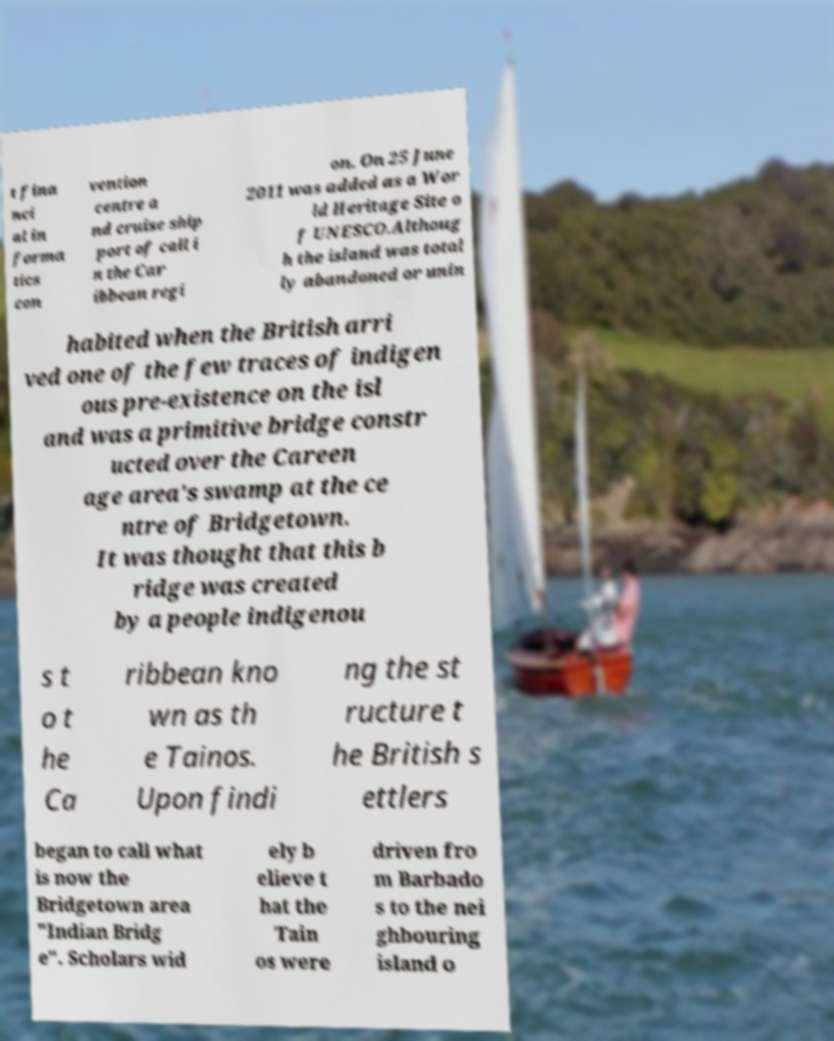There's text embedded in this image that I need extracted. Can you transcribe it verbatim? t fina nci al in forma tics con vention centre a nd cruise ship port of call i n the Car ibbean regi on. On 25 June 2011 was added as a Wor ld Heritage Site o f UNESCO.Althoug h the island was total ly abandoned or unin habited when the British arri ved one of the few traces of indigen ous pre-existence on the isl and was a primitive bridge constr ucted over the Careen age area's swamp at the ce ntre of Bridgetown. It was thought that this b ridge was created by a people indigenou s t o t he Ca ribbean kno wn as th e Tainos. Upon findi ng the st ructure t he British s ettlers began to call what is now the Bridgetown area "Indian Bridg e". Scholars wid ely b elieve t hat the Tain os were driven fro m Barbado s to the nei ghbouring island o 